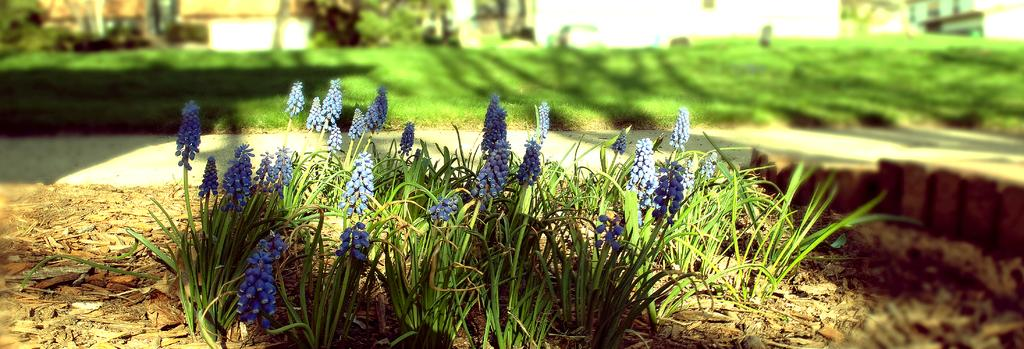What color are the flowers in the image? The flowers in the image are purple. What color are the leaves in the image? The leaves in the image are green. What color is the background of the image? The background of the image is green. How is the background of the image depicted? The background of the image is blurred. What type of voice can be heard coming from the flowers in the image? There is no voice present in the image, as flowers do not have the ability to produce sound. 